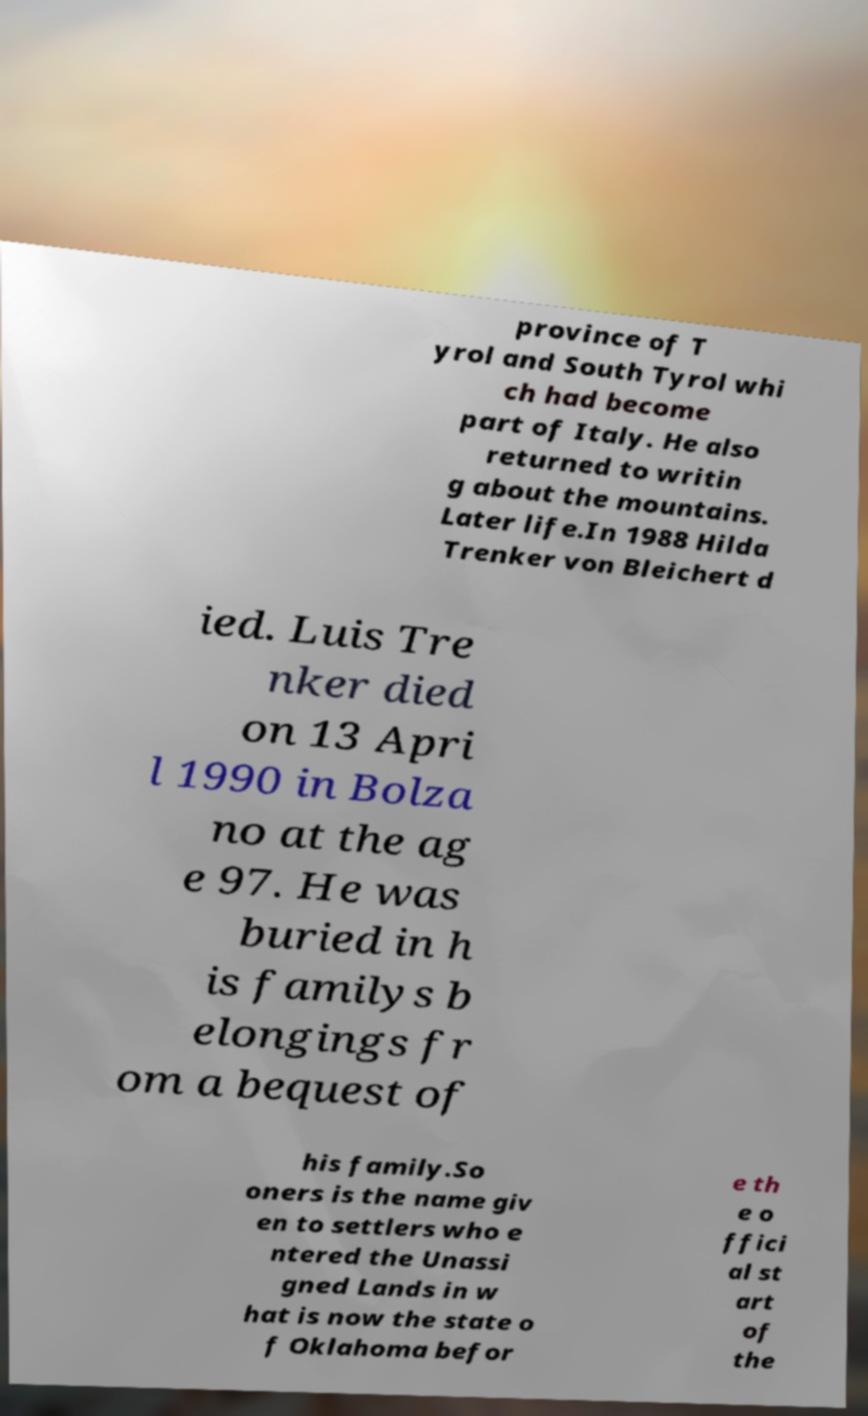Could you assist in decoding the text presented in this image and type it out clearly? province of T yrol and South Tyrol whi ch had become part of Italy. He also returned to writin g about the mountains. Later life.In 1988 Hilda Trenker von Bleichert d ied. Luis Tre nker died on 13 Apri l 1990 in Bolza no at the ag e 97. He was buried in h is familys b elongings fr om a bequest of his family.So oners is the name giv en to settlers who e ntered the Unassi gned Lands in w hat is now the state o f Oklahoma befor e th e o ffici al st art of the 